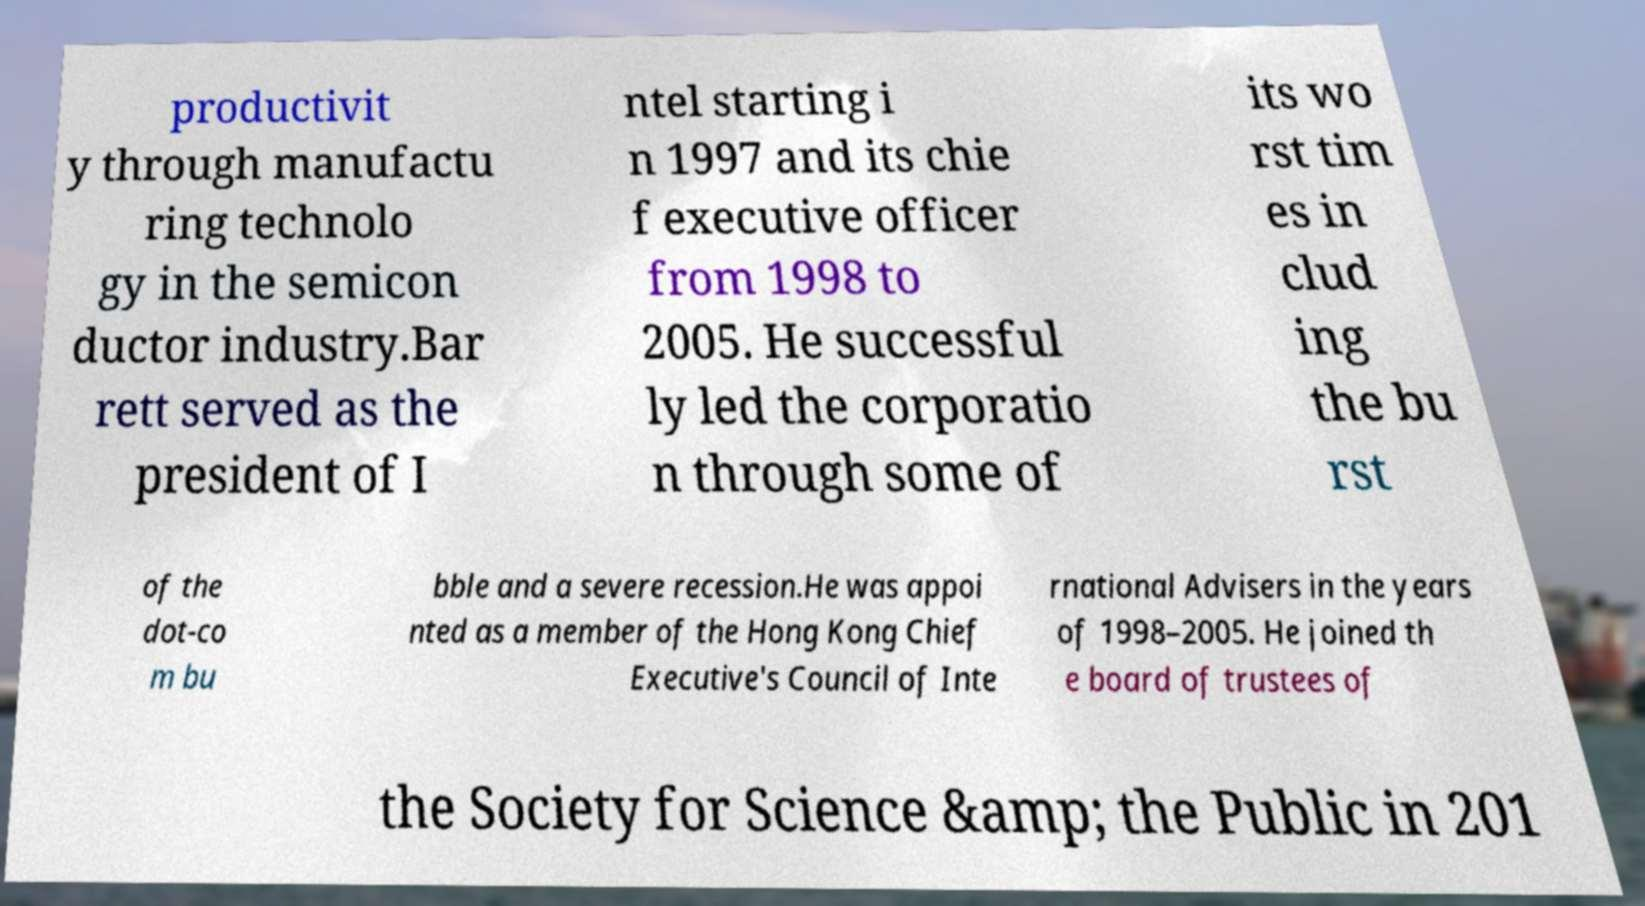Could you extract and type out the text from this image? productivit y through manufactu ring technolo gy in the semicon ductor industry.Bar rett served as the president of I ntel starting i n 1997 and its chie f executive officer from 1998 to 2005. He successful ly led the corporatio n through some of its wo rst tim es in clud ing the bu rst of the dot-co m bu bble and a severe recession.He was appoi nted as a member of the Hong Kong Chief Executive's Council of Inte rnational Advisers in the years of 1998–2005. He joined th e board of trustees of the Society for Science &amp; the Public in 201 